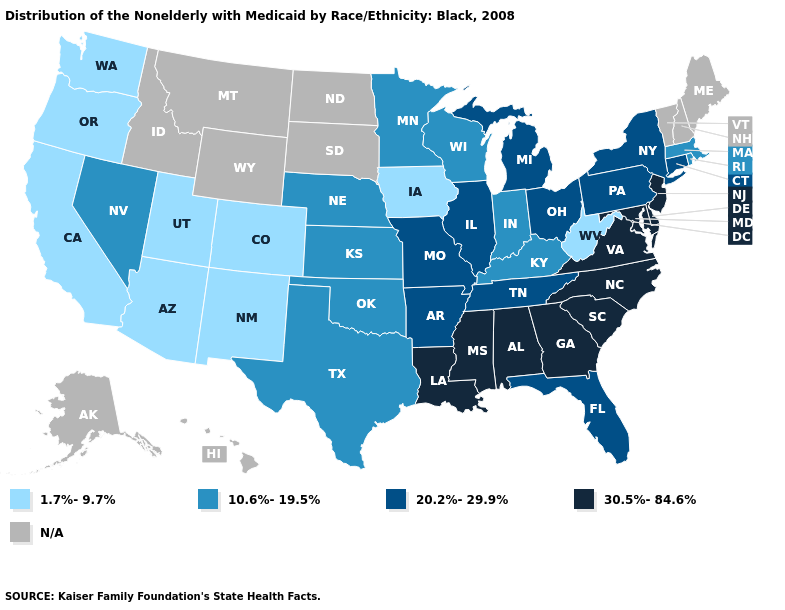What is the value of New York?
Short answer required. 20.2%-29.9%. Does Iowa have the lowest value in the MidWest?
Give a very brief answer. Yes. Is the legend a continuous bar?
Short answer required. No. Name the states that have a value in the range 10.6%-19.5%?
Short answer required. Indiana, Kansas, Kentucky, Massachusetts, Minnesota, Nebraska, Nevada, Oklahoma, Rhode Island, Texas, Wisconsin. What is the value of South Dakota?
Write a very short answer. N/A. What is the value of Vermont?
Concise answer only. N/A. Among the states that border Tennessee , which have the highest value?
Keep it brief. Alabama, Georgia, Mississippi, North Carolina, Virginia. Does Iowa have the lowest value in the MidWest?
Quick response, please. Yes. Among the states that border Oklahoma , does Missouri have the highest value?
Give a very brief answer. Yes. What is the value of North Dakota?
Concise answer only. N/A. What is the value of Pennsylvania?
Answer briefly. 20.2%-29.9%. What is the highest value in the West ?
Give a very brief answer. 10.6%-19.5%. How many symbols are there in the legend?
Answer briefly. 5. 